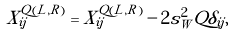<formula> <loc_0><loc_0><loc_500><loc_500>\tilde { X } ^ { Q ( L , R ) } _ { i j } = X ^ { Q ( L , R ) } _ { i j } - 2 s _ { W } ^ { 2 } Q \delta _ { i j } ,</formula> 